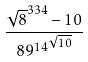Convert formula to latex. <formula><loc_0><loc_0><loc_500><loc_500>\frac { \sqrt { 8 } ^ { 3 3 4 } - 1 0 } { { 8 9 ^ { 1 4 } } ^ { \sqrt { 1 0 } } }</formula> 